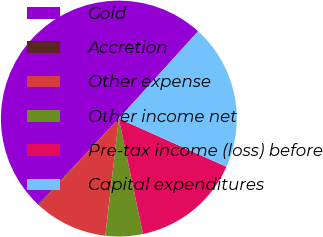Convert chart. <chart><loc_0><loc_0><loc_500><loc_500><pie_chart><fcel>Gold<fcel>Accretion<fcel>Other expense<fcel>Other income net<fcel>Pre-tax income (loss) before<fcel>Capital expenditures<nl><fcel>49.69%<fcel>0.15%<fcel>10.06%<fcel>5.11%<fcel>15.02%<fcel>19.97%<nl></chart> 